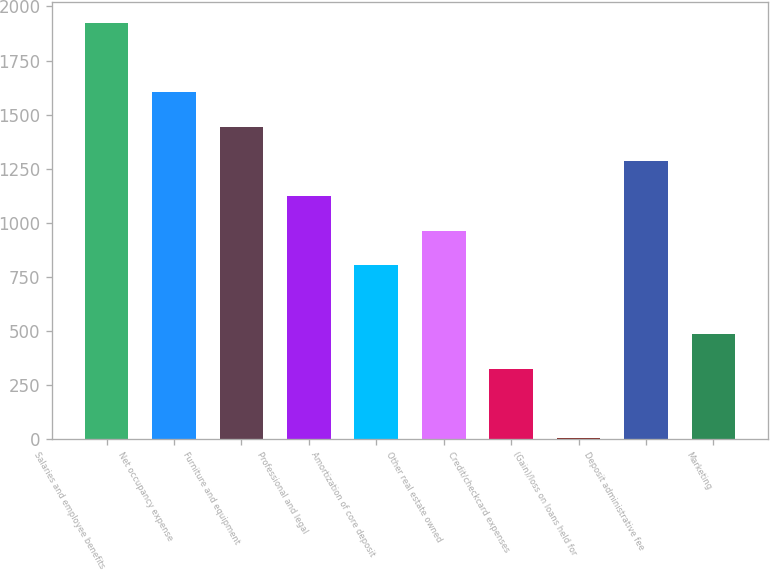Convert chart to OTSL. <chart><loc_0><loc_0><loc_500><loc_500><bar_chart><fcel>Salaries and employee benefits<fcel>Net occupancy expense<fcel>Furniture and equipment<fcel>Professional and legal<fcel>Amortization of core deposit<fcel>Other real estate owned<fcel>Credit/checkcard expenses<fcel>(Gain)/loss on loans held for<fcel>Deposit administrative fee<fcel>Marketing<nl><fcel>1924.6<fcel>1604<fcel>1443.7<fcel>1123.1<fcel>802.5<fcel>962.8<fcel>321.6<fcel>1<fcel>1283.4<fcel>481.9<nl></chart> 